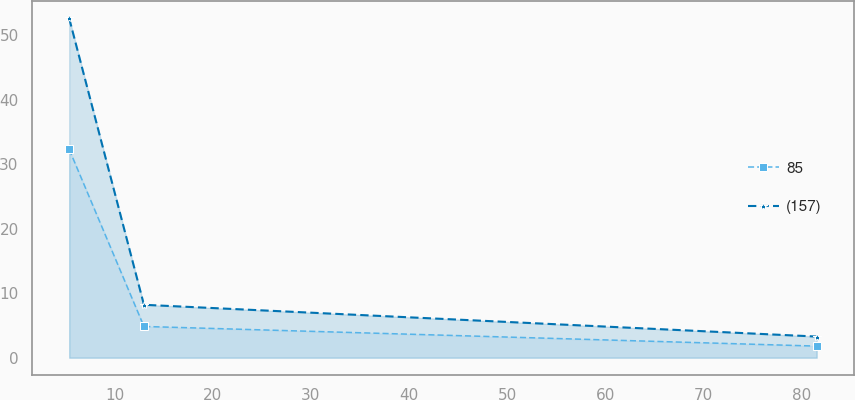Convert chart to OTSL. <chart><loc_0><loc_0><loc_500><loc_500><line_chart><ecel><fcel>85<fcel>(157)<nl><fcel>5.35<fcel>32.31<fcel>52.63<nl><fcel>12.97<fcel>4.85<fcel>8.21<nl><fcel>81.58<fcel>1.8<fcel>3.28<nl></chart> 